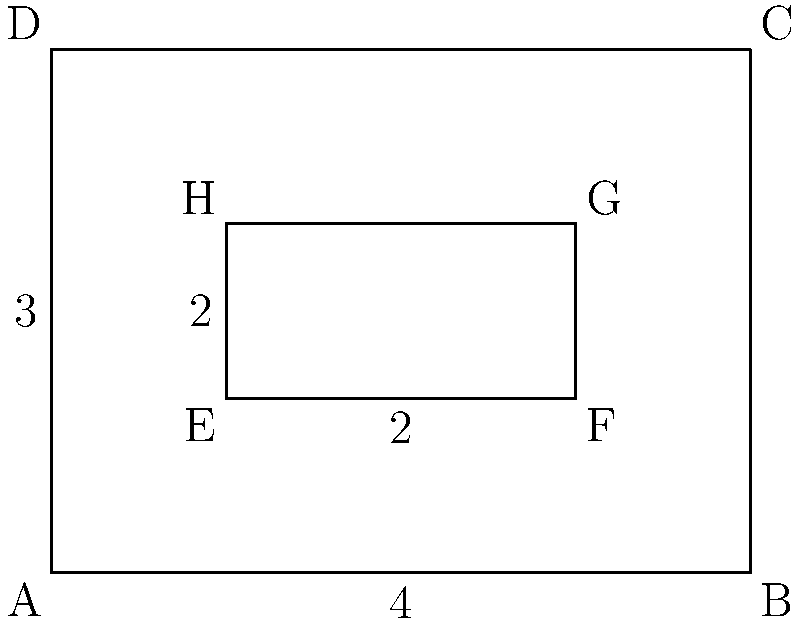In designing a costume for your latest opera, you've incorporated a rectangular pattern within a larger rectangle, as shown in the diagram. The outer rectangle ABCD has dimensions 4 units by 3 units, while the inner rectangle EFGH has dimensions 2 units by 1 unit. To maintain the costume's proportions, you need to prove that triangles AED and CGF are congruent. Which congruence criterion would you use to prove this, and what additional information would you need? To prove that triangles AED and CGF are congruent, we can use the ASA (Angle-Side-Angle) congruence criterion. Here's the step-by-step explanation:

1) First, we need to establish that these triangles share some properties:

   a) $\angle DAE \cong \angle GCF$ (corresponding angles of parallel lines AD and CG)
   b) $\angle AED \cong \angle CGF$ (both are right angles)

2) To use ASA, we need to prove that one pair of corresponding sides is congruent. In this case, we need to show that AE = CG.

3) To prove AE = CG:
   a) AE = AD - ED = 3 - 1 = 2
   b) CG = CB - FG = 4 - 2 = 2

4) Now we have:
   - $\angle DAE \cong \angle GCF$ (corresponding angles)
   - AE = CG (proved in step 3)
   - $\angle AED \cong \angle CGF$ (right angles)

5) With two pairs of congruent angles and the included side congruent, we can apply the ASA congruence criterion to conclude that triangles AED and CGF are congruent.

The additional information needed was the length of AE (or CG), which we derived from the given dimensions of the rectangles.
Answer: ASA criterion; AE = CG = 2 